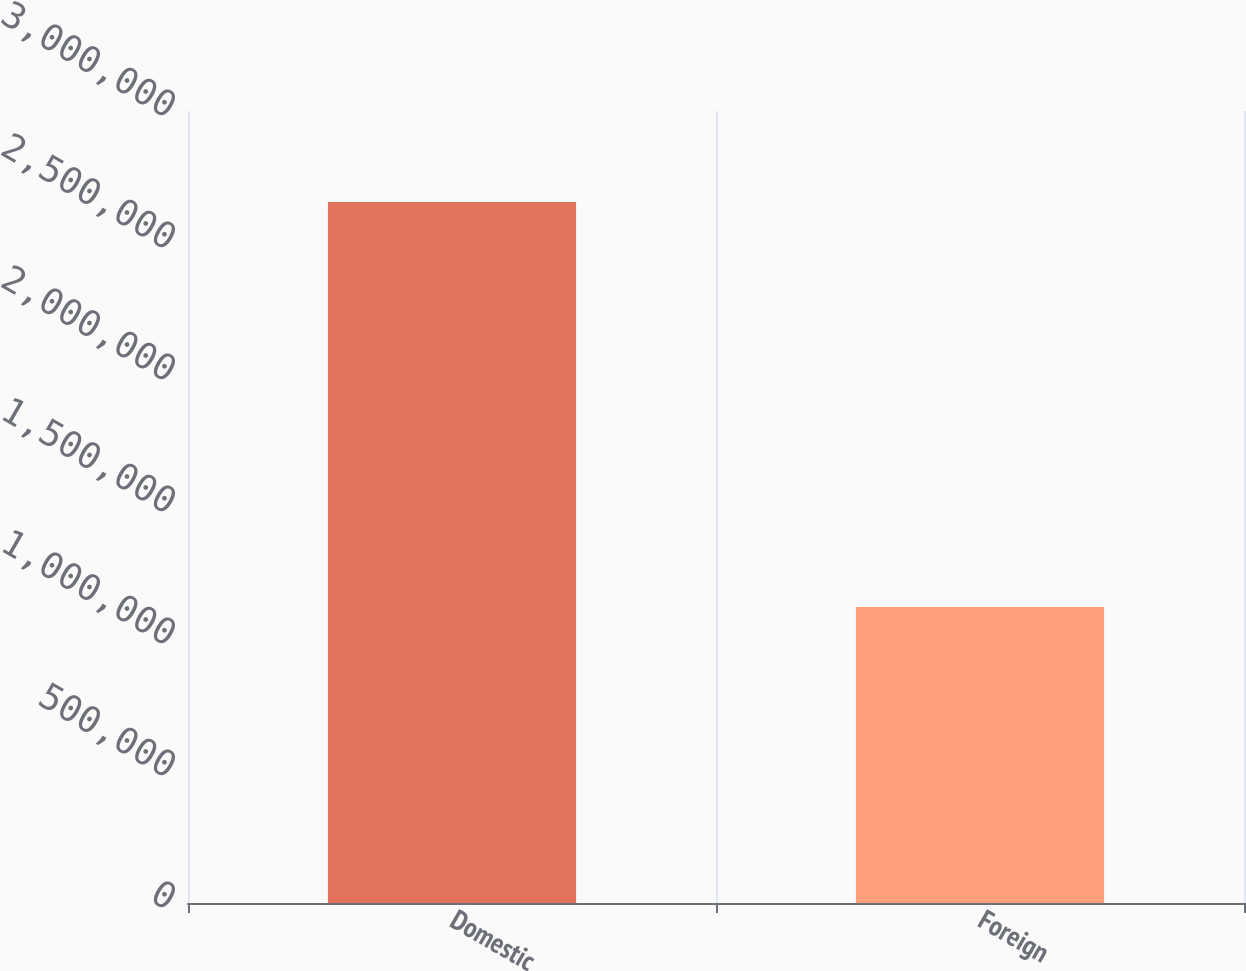Convert chart. <chart><loc_0><loc_0><loc_500><loc_500><bar_chart><fcel>Domestic<fcel>Foreign<nl><fcel>2.65544e+06<fcel>1.12153e+06<nl></chart> 